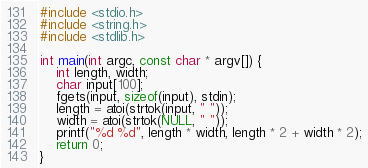<code> <loc_0><loc_0><loc_500><loc_500><_C_>#include <stdio.h>
#include <string.h>
#include <stdlib.h>

int main(int argc, const char * argv[]) {
    int length, width;
    char input[100];
    fgets(input, sizeof(input), stdin);
    length = atoi(strtok(input, " "));
    width = atoi(strtok(NULL, " "));
    printf("%d %d", length * width, length * 2 + width * 2);
    return 0;
}</code> 